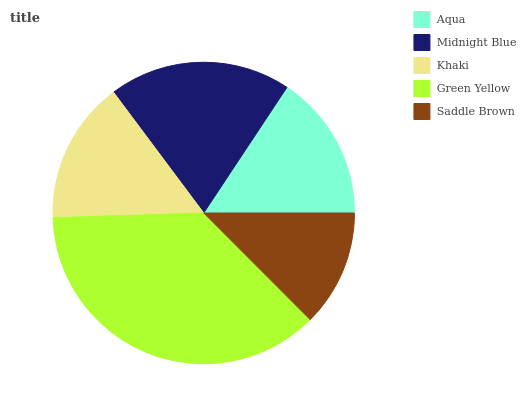Is Saddle Brown the minimum?
Answer yes or no. Yes. Is Green Yellow the maximum?
Answer yes or no. Yes. Is Midnight Blue the minimum?
Answer yes or no. No. Is Midnight Blue the maximum?
Answer yes or no. No. Is Midnight Blue greater than Aqua?
Answer yes or no. Yes. Is Aqua less than Midnight Blue?
Answer yes or no. Yes. Is Aqua greater than Midnight Blue?
Answer yes or no. No. Is Midnight Blue less than Aqua?
Answer yes or no. No. Is Aqua the high median?
Answer yes or no. Yes. Is Aqua the low median?
Answer yes or no. Yes. Is Khaki the high median?
Answer yes or no. No. Is Midnight Blue the low median?
Answer yes or no. No. 